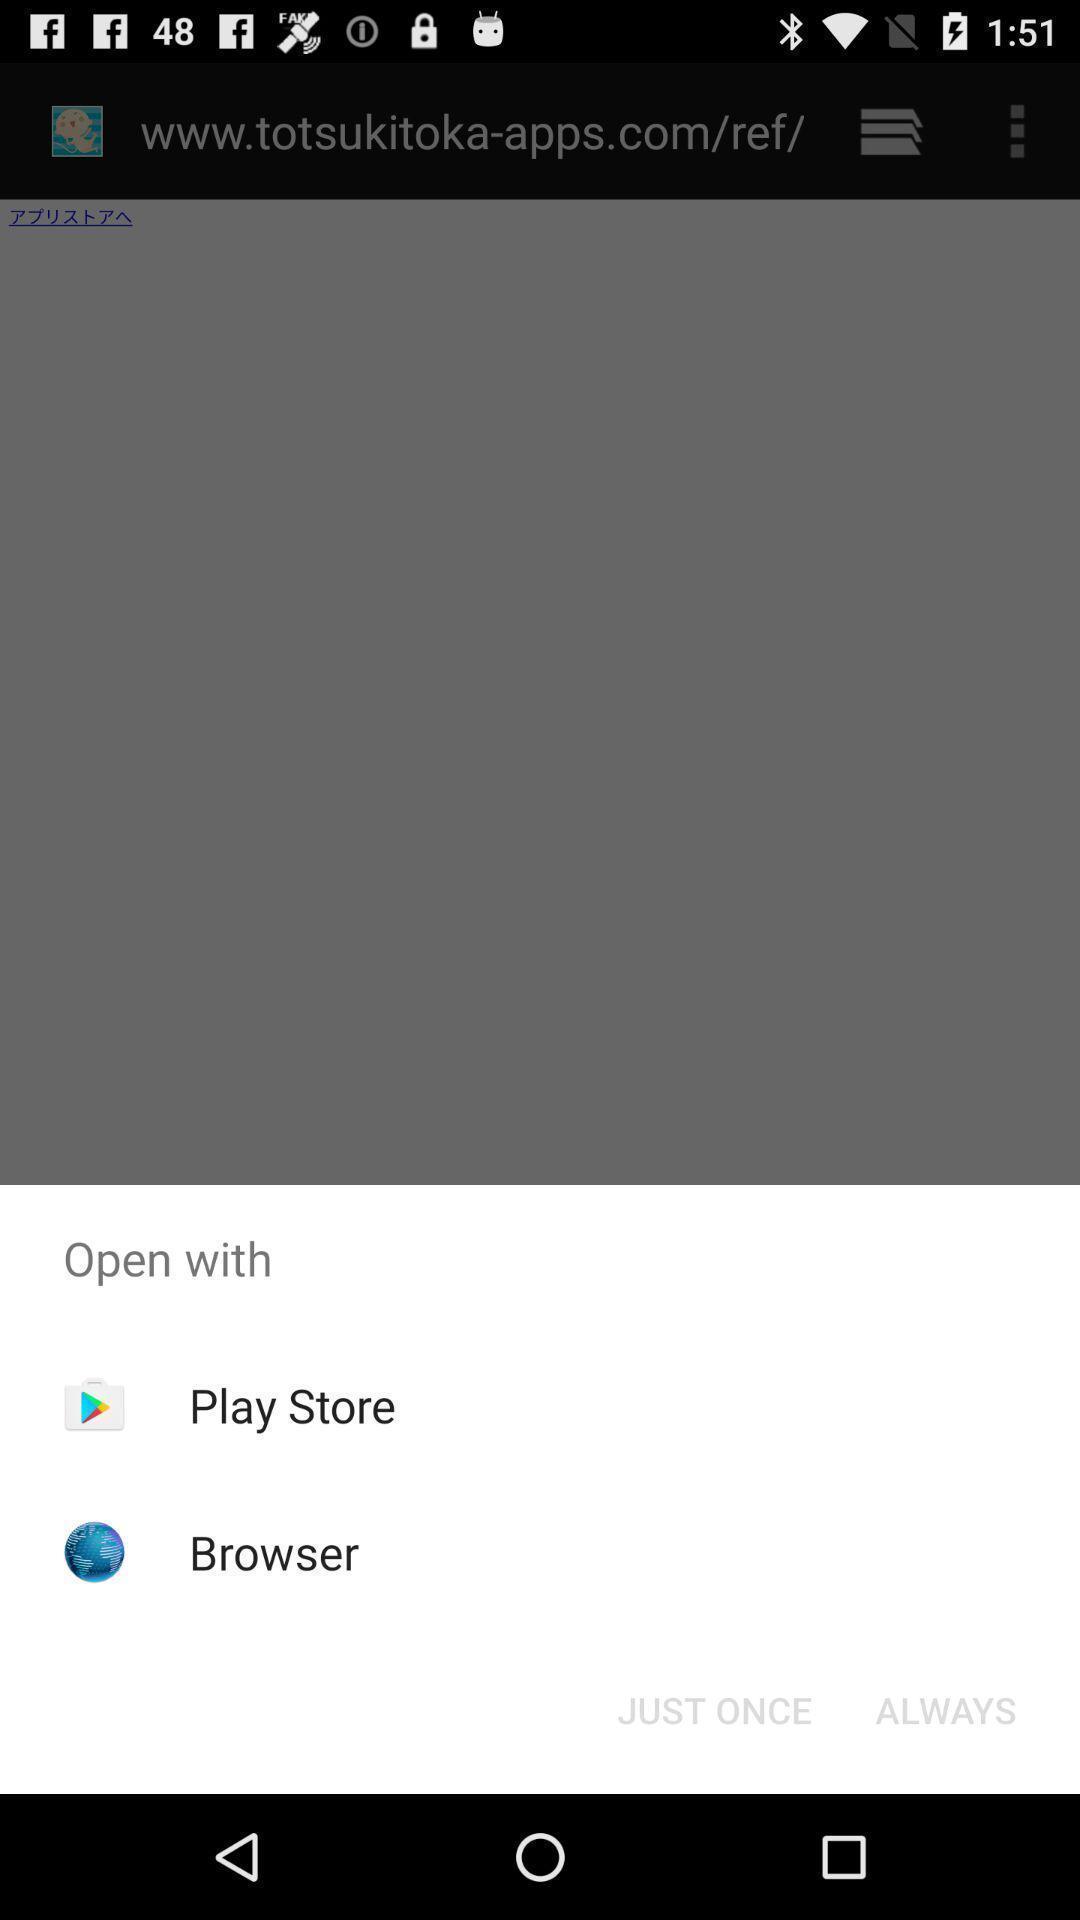Describe the content in this image. Popup page for opening through different apps. 